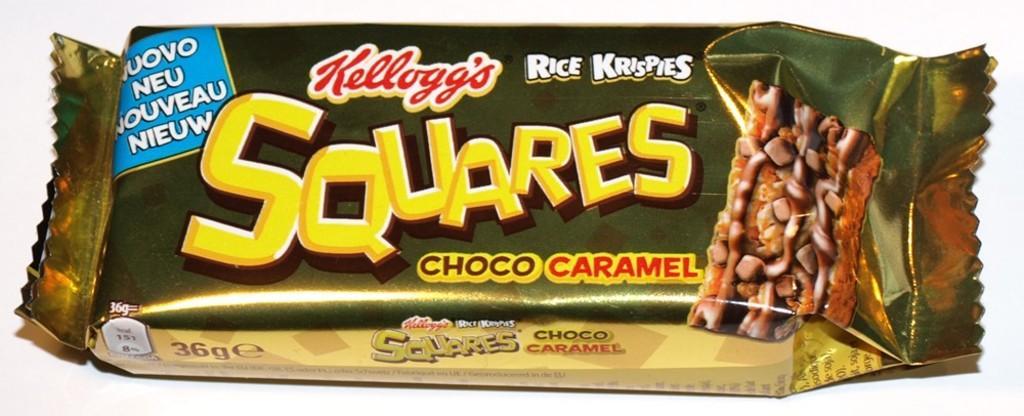Can you describe this image briefly? In this picture we can see a chocolate packet, there is some text and picture of a chocolate on this packet, we can see a white color background. 